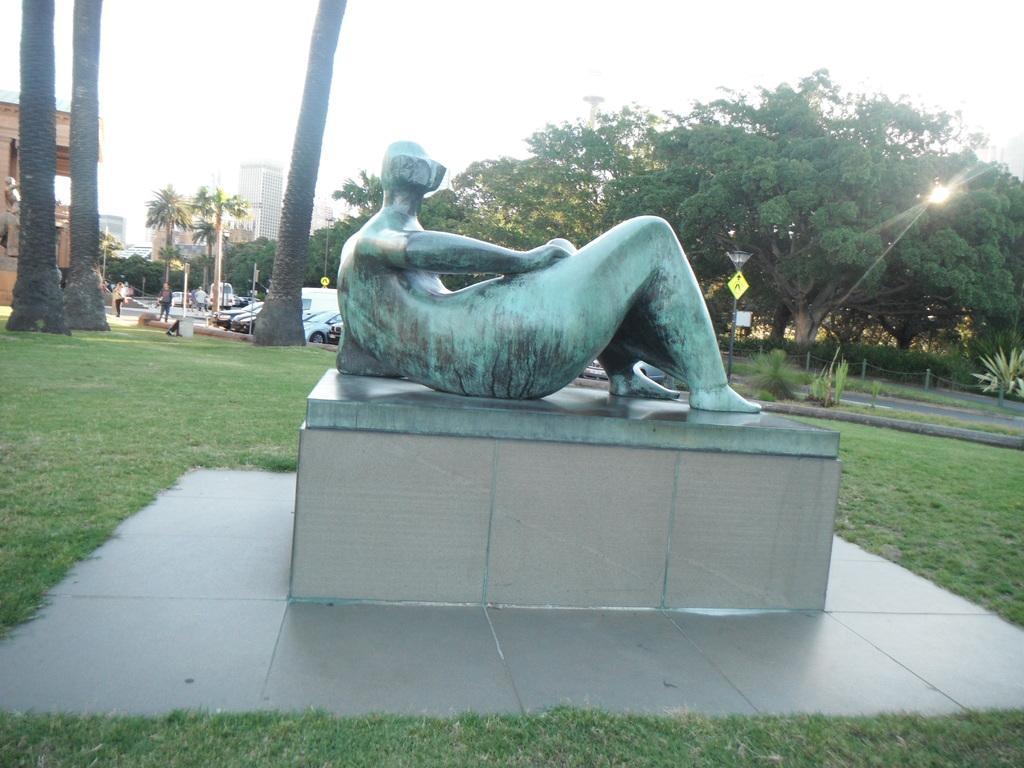Please provide a concise description of this image. In the image in the center we can see one stone. On stone,we can see statue. In the background we can see sky,clouds,buildings,wall,trees,vehicles,sign boards,poles,plants,grass and few people were standing. 